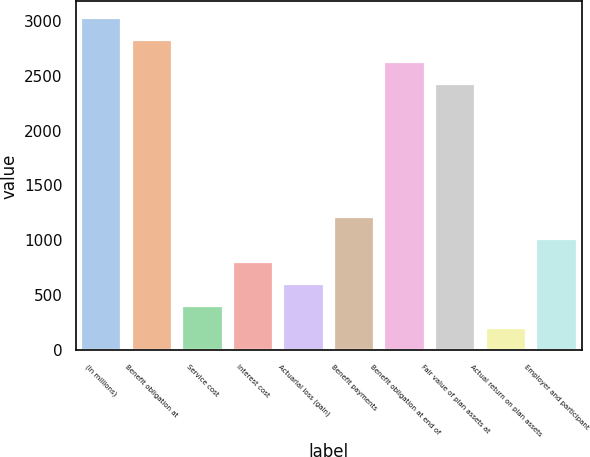Convert chart to OTSL. <chart><loc_0><loc_0><loc_500><loc_500><bar_chart><fcel>(In millions)<fcel>Benefit obligation at<fcel>Service cost<fcel>Interest cost<fcel>Actuarial loss (gain)<fcel>Benefit payments<fcel>Benefit obligation at end of<fcel>Fair value of plan assets at<fcel>Actual return on plan assets<fcel>Employer and participant<nl><fcel>3023<fcel>2821.6<fcel>404.8<fcel>807.6<fcel>606.2<fcel>1210.4<fcel>2620.2<fcel>2418.8<fcel>203.4<fcel>1009<nl></chart> 